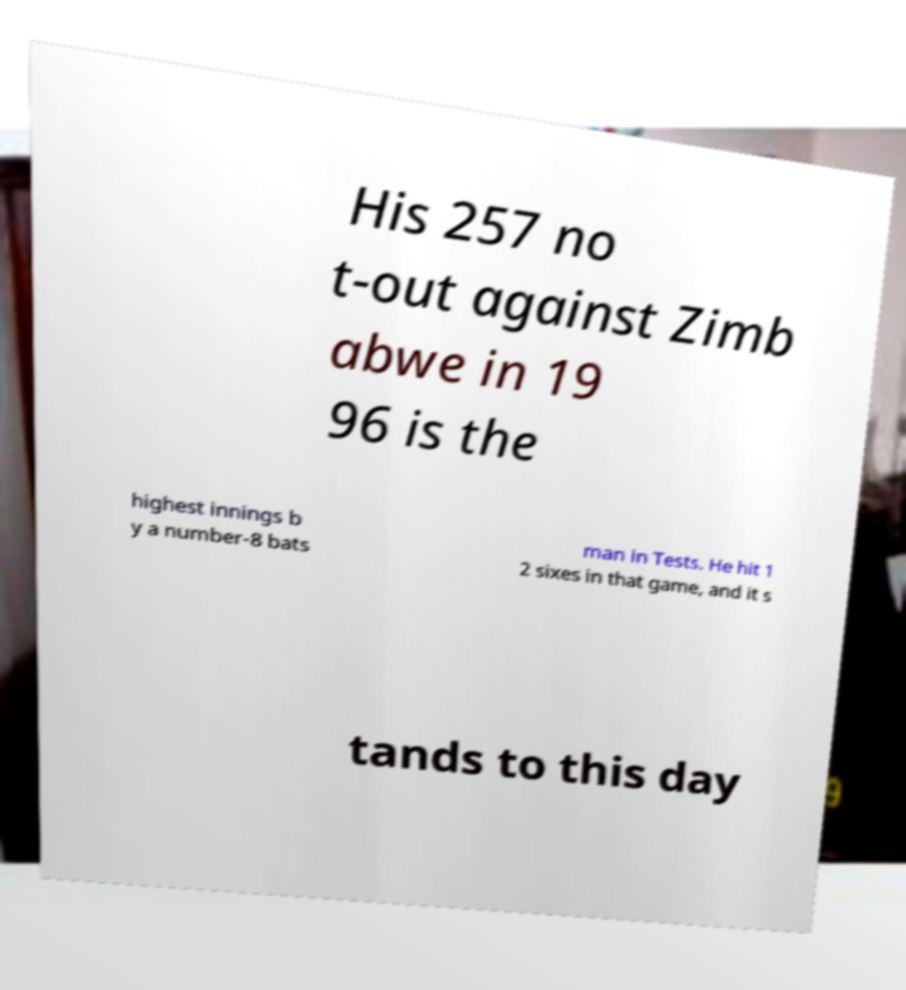Please read and relay the text visible in this image. What does it say? His 257 no t-out against Zimb abwe in 19 96 is the highest innings b y a number-8 bats man in Tests. He hit 1 2 sixes in that game, and it s tands to this day 